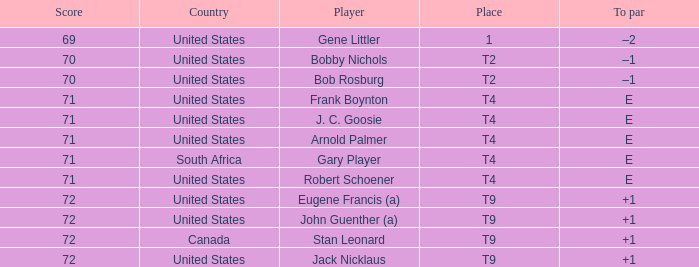What is To Par, when Country is "United States", when Place is "T4", and when Player is "Frank Boynton"? E. 